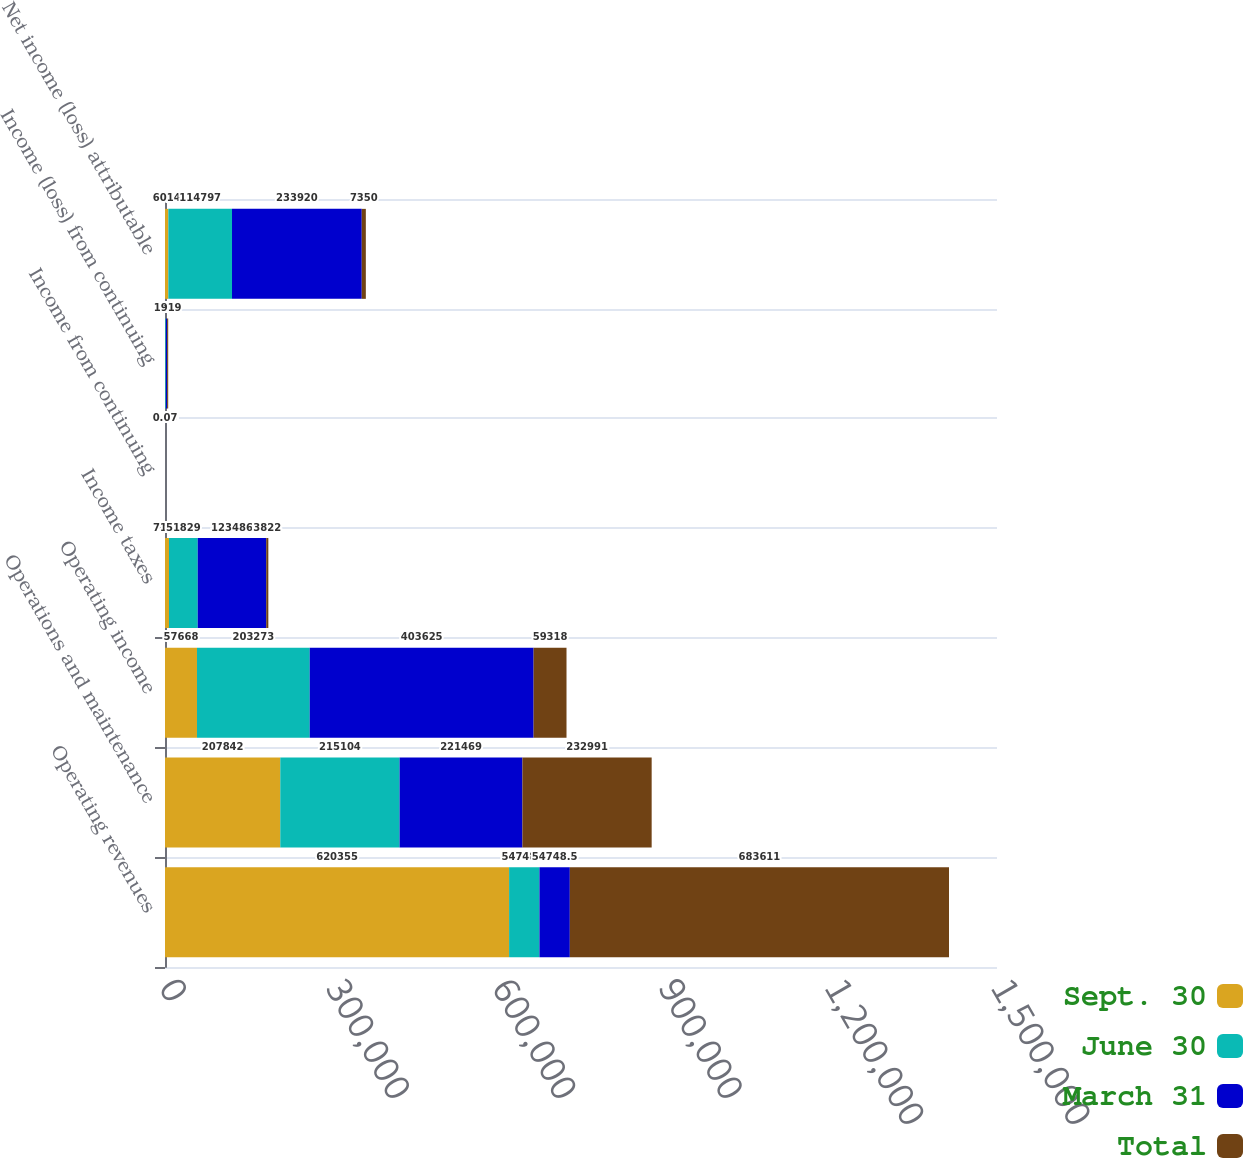Convert chart to OTSL. <chart><loc_0><loc_0><loc_500><loc_500><stacked_bar_chart><ecel><fcel>Operating revenues<fcel>Operations and maintenance<fcel>Operating income<fcel>Income taxes<fcel>Income from continuing<fcel>Income (loss) from continuing<fcel>Net income (loss) attributable<nl><fcel>Sept. 30<fcel>620355<fcel>207842<fcel>57668<fcel>7172<fcel>0.07<fcel>292<fcel>6014<nl><fcel>June 30<fcel>54748.5<fcel>215104<fcel>203273<fcel>51829<fcel>0.84<fcel>1270<fcel>114797<nl><fcel>March 31<fcel>54748.5<fcel>221469<fcel>403625<fcel>123486<fcel>2.09<fcel>2266<fcel>233920<nl><fcel>Total<fcel>683611<fcel>232991<fcel>59318<fcel>3822<fcel>0.07<fcel>1919<fcel>7350<nl></chart> 